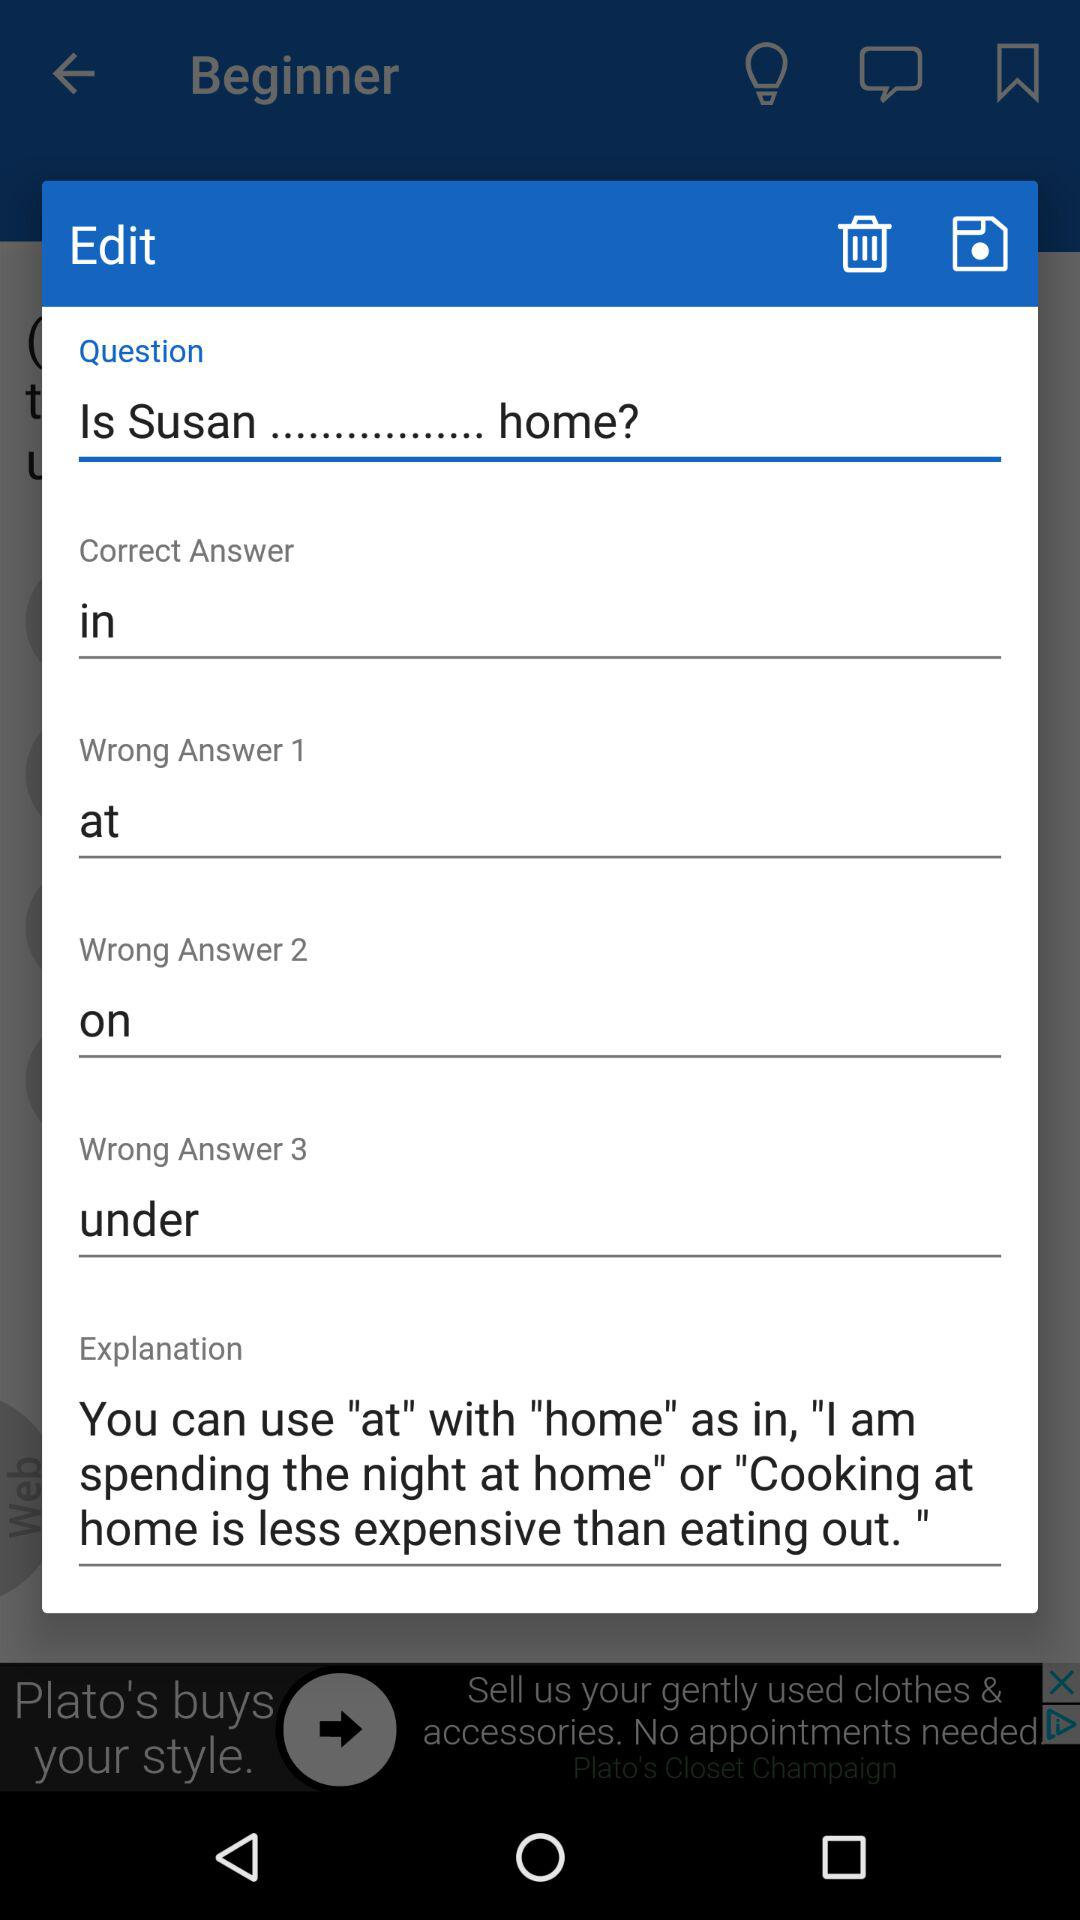What's the "Explanation"?
Answer the question using a single word or phrase. The "Explanation" is: You can use "at" with "home" as in, "I am spending the night at home" or "Cooking at home is less expensive than eating out. " 